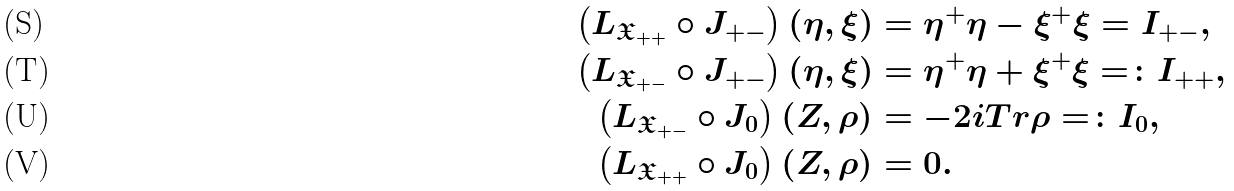<formula> <loc_0><loc_0><loc_500><loc_500>\left ( L _ { \mathfrak { X } _ { + + } } \circ J _ { + - } \right ) ( \eta , \xi ) & = \eta ^ { + } \eta - \xi ^ { + } \xi = I _ { + - } , \\ \left ( L _ { \mathfrak { X } _ { + - } } \circ J _ { + - } \right ) ( \eta , \xi ) & = \eta ^ { + } \eta + \xi ^ { + } \xi = \colon I _ { + + } , \\ \left ( L _ { \mathfrak { X } _ { + - } } \circ J _ { 0 } \right ) ( Z , \rho ) & = - 2 i T r \rho = \colon I _ { 0 } , \\ \left ( L _ { \mathfrak { X } _ { + + } } \circ J _ { 0 } \right ) ( Z , \rho ) & = 0 .</formula> 